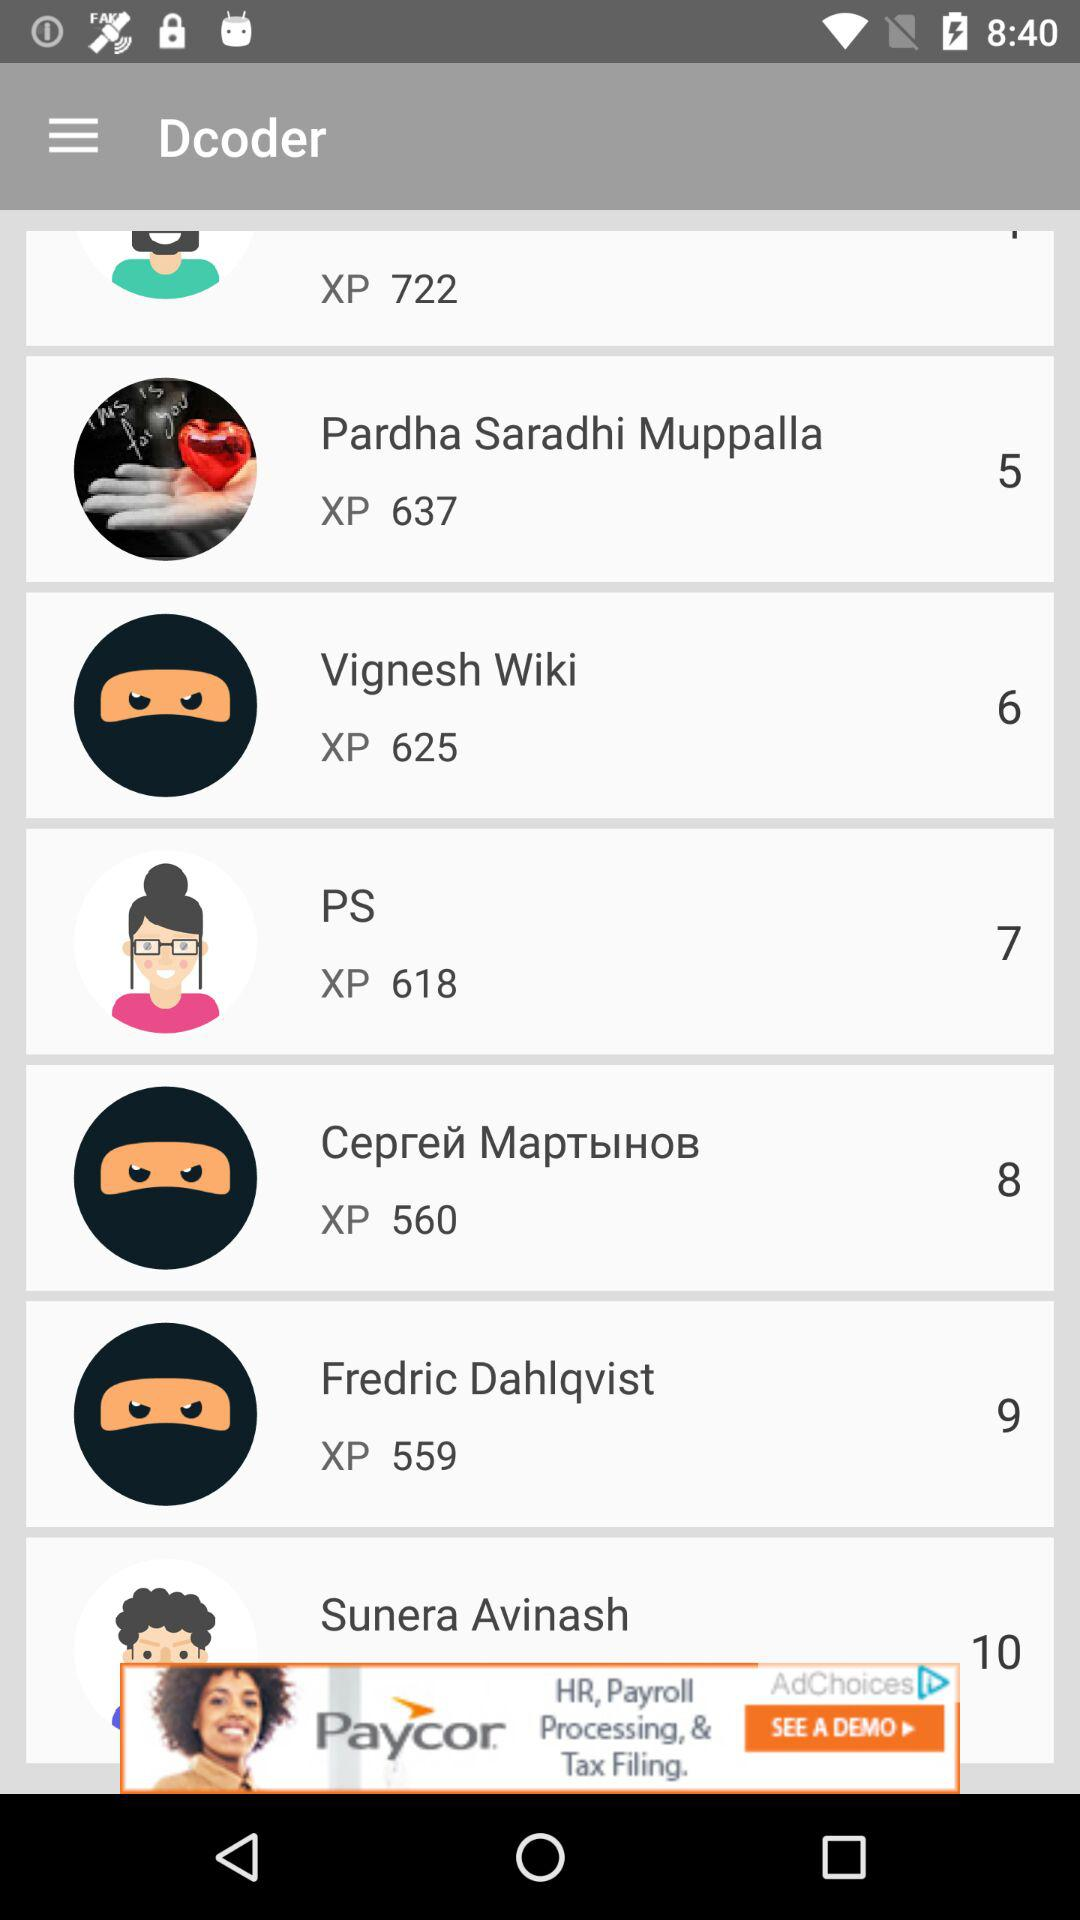Who got 9 points? The one who got 9 points is Fredric Dahlqvist. 